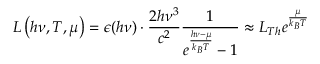<formula> <loc_0><loc_0><loc_500><loc_500>L \left ( h \nu , T , \mu \right ) = \epsilon ( h \nu ) \cdot \frac { 2 h \nu ^ { 3 } } { c ^ { 2 } } \frac { 1 } { e ^ { \frac { h \nu - \mu } { k _ { B } T } } - 1 } \approx L _ { T h } e ^ { \frac { \mu } { k _ { B } T } }</formula> 